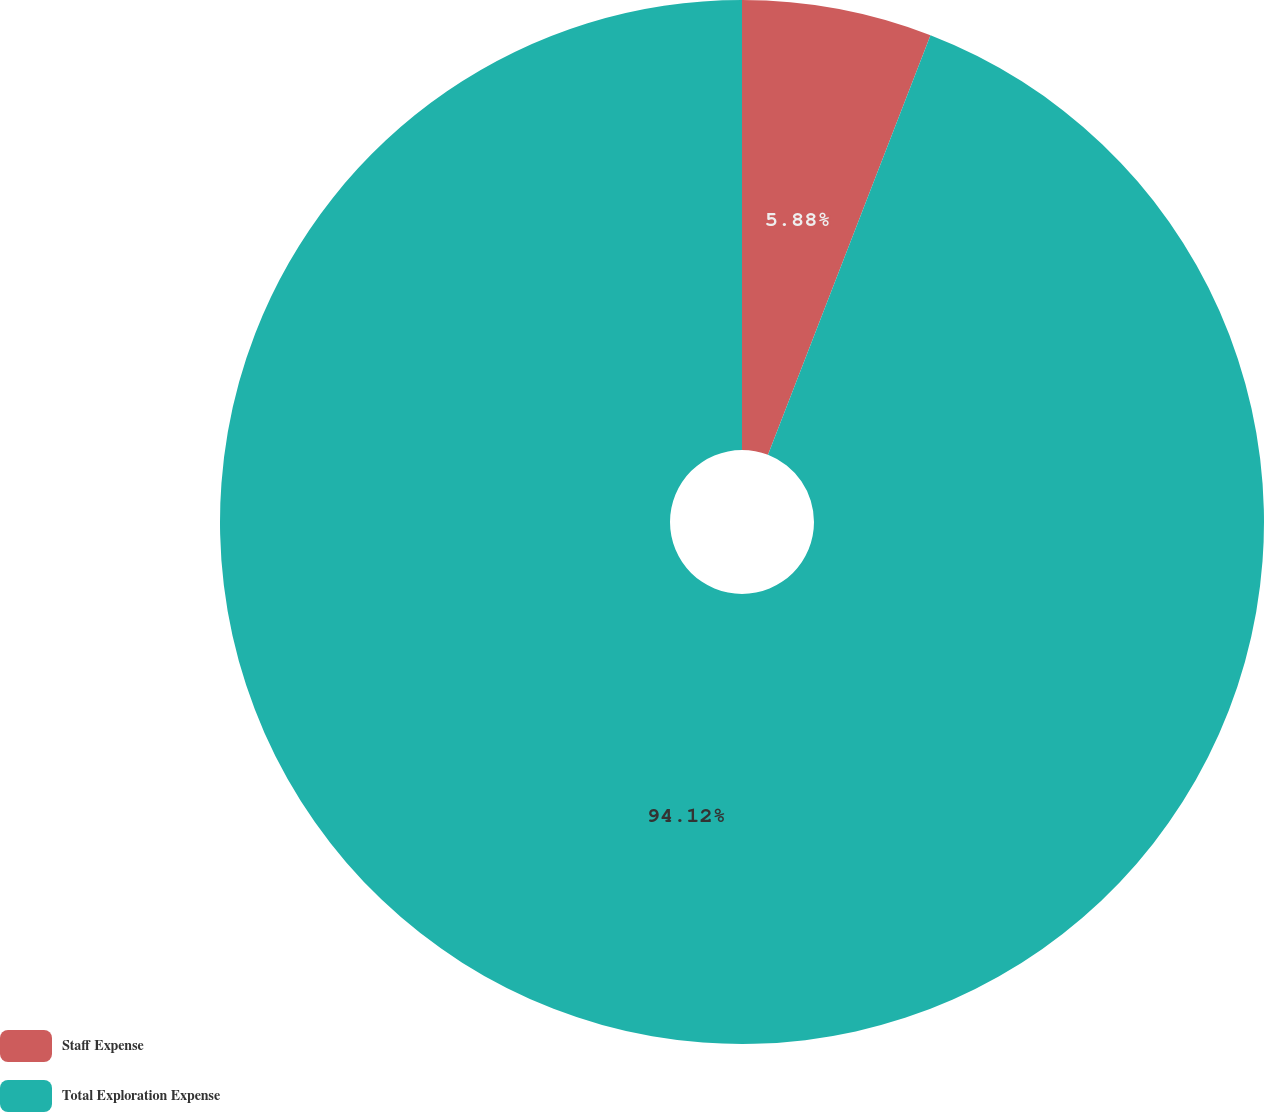Convert chart. <chart><loc_0><loc_0><loc_500><loc_500><pie_chart><fcel>Staff Expense<fcel>Total Exploration Expense<nl><fcel>5.88%<fcel>94.12%<nl></chart> 